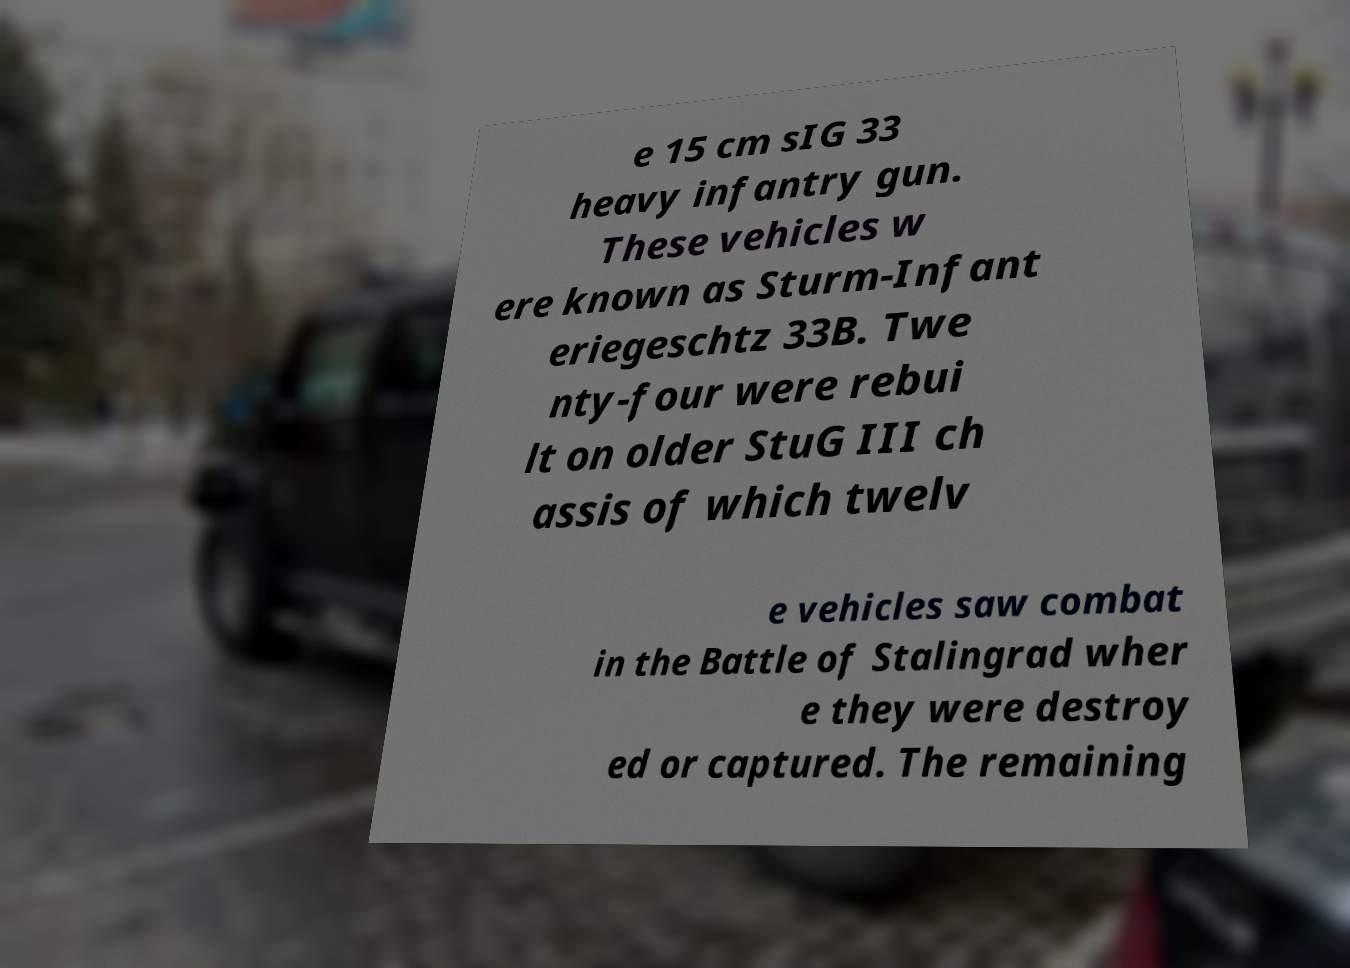Please identify and transcribe the text found in this image. e 15 cm sIG 33 heavy infantry gun. These vehicles w ere known as Sturm-Infant eriegeschtz 33B. Twe nty-four were rebui lt on older StuG III ch assis of which twelv e vehicles saw combat in the Battle of Stalingrad wher e they were destroy ed or captured. The remaining 